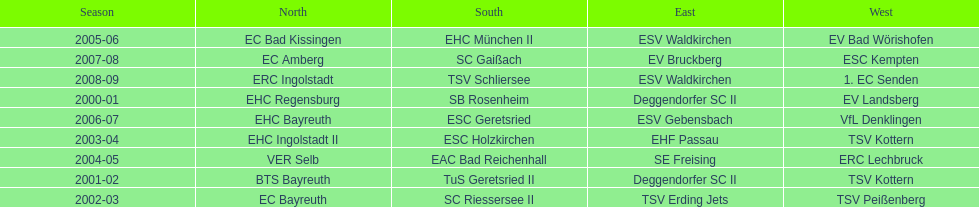Could you parse the entire table? {'header': ['Season', 'North', 'South', 'East', 'West'], 'rows': [['2005-06', 'EC Bad Kissingen', 'EHC München II', 'ESV Waldkirchen', 'EV Bad Wörishofen'], ['2007-08', 'EC Amberg', 'SC Gaißach', 'EV Bruckberg', 'ESC Kempten'], ['2008-09', 'ERC Ingolstadt', 'TSV Schliersee', 'ESV Waldkirchen', '1. EC Senden'], ['2000-01', 'EHC Regensburg', 'SB Rosenheim', 'Deggendorfer SC II', 'EV Landsberg'], ['2006-07', 'EHC Bayreuth', 'ESC Geretsried', 'ESV Gebensbach', 'VfL Denklingen'], ['2003-04', 'EHC Ingolstadt II', 'ESC Holzkirchen', 'EHF Passau', 'TSV Kottern'], ['2004-05', 'VER Selb', 'EAC Bad Reichenhall', 'SE Freising', 'ERC Lechbruck'], ['2001-02', 'BTS Bayreuth', 'TuS Geretsried II', 'Deggendorfer SC II', 'TSV Kottern'], ['2002-03', 'EC Bayreuth', 'SC Riessersee II', 'TSV Erding Jets', 'TSV Peißenberg']]} Who won the season in the north before ec bayreuth did in 2002-03? BTS Bayreuth. 